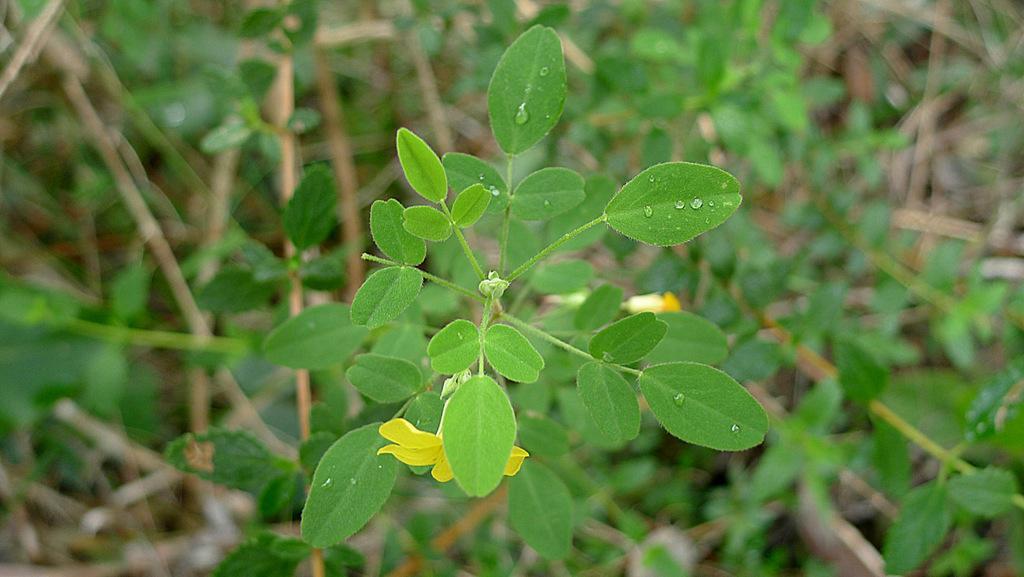Please provide a concise description of this image. In this image we can see a few plants in which one of the plants contains yellow flower. 